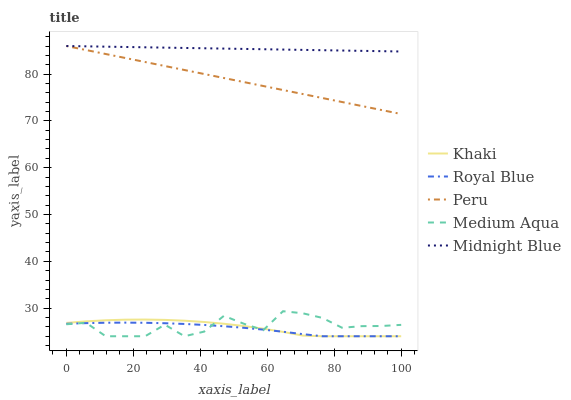Does Royal Blue have the minimum area under the curve?
Answer yes or no. Yes. Does Midnight Blue have the maximum area under the curve?
Answer yes or no. Yes. Does Khaki have the minimum area under the curve?
Answer yes or no. No. Does Khaki have the maximum area under the curve?
Answer yes or no. No. Is Peru the smoothest?
Answer yes or no. Yes. Is Medium Aqua the roughest?
Answer yes or no. Yes. Is Khaki the smoothest?
Answer yes or no. No. Is Khaki the roughest?
Answer yes or no. No. Does Midnight Blue have the lowest value?
Answer yes or no. No. Does Peru have the highest value?
Answer yes or no. Yes. Does Khaki have the highest value?
Answer yes or no. No. Is Medium Aqua less than Peru?
Answer yes or no. Yes. Is Peru greater than Royal Blue?
Answer yes or no. Yes. Does Khaki intersect Medium Aqua?
Answer yes or no. Yes. Is Khaki less than Medium Aqua?
Answer yes or no. No. Is Khaki greater than Medium Aqua?
Answer yes or no. No. Does Medium Aqua intersect Peru?
Answer yes or no. No. 